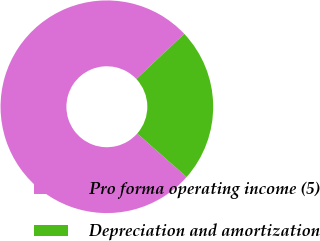Convert chart. <chart><loc_0><loc_0><loc_500><loc_500><pie_chart><fcel>Pro forma operating income (5)<fcel>Depreciation and amortization<nl><fcel>76.48%<fcel>23.52%<nl></chart> 